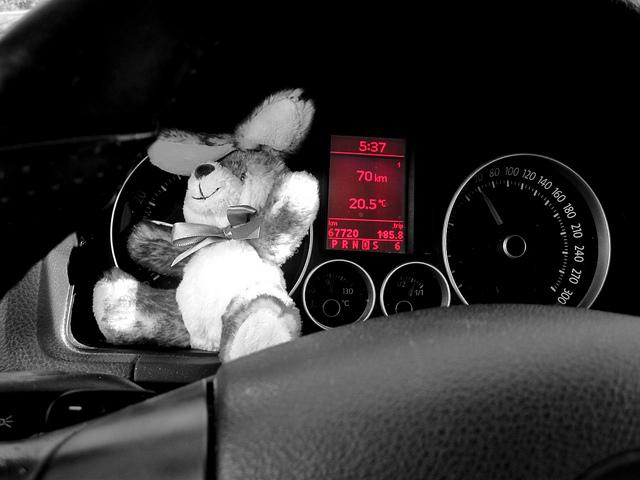Was this picture taken in the daytime?
Concise answer only. Yes. What is on the dashboard?
Concise answer only. Stuffed rabbit. What color is the bunny?
Quick response, please. White. 